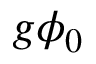<formula> <loc_0><loc_0><loc_500><loc_500>g \phi _ { 0 }</formula> 